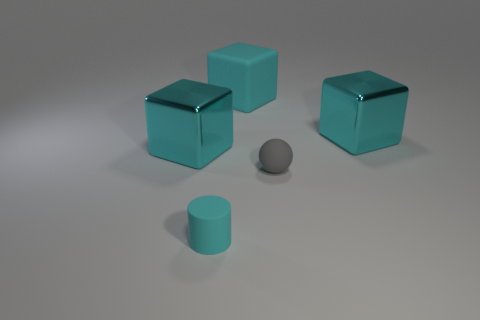How many cyan blocks must be subtracted to get 2 cyan blocks? 1 Add 5 cyan rubber objects. How many objects exist? 10 Subtract all spheres. How many objects are left? 4 Add 2 cyan cubes. How many cyan cubes exist? 5 Subtract 0 brown cylinders. How many objects are left? 5 Subtract all tiny cylinders. Subtract all large blue shiny cubes. How many objects are left? 4 Add 3 large cyan objects. How many large cyan objects are left? 6 